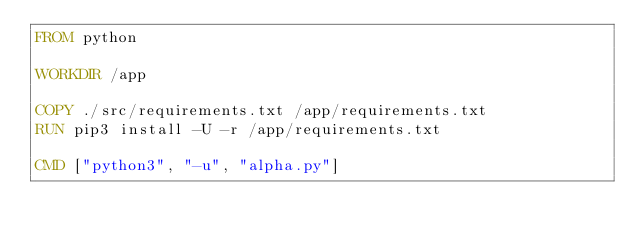Convert code to text. <code><loc_0><loc_0><loc_500><loc_500><_Dockerfile_>FROM python

WORKDIR /app

COPY ./src/requirements.txt /app/requirements.txt
RUN pip3 install -U -r /app/requirements.txt

CMD ["python3", "-u", "alpha.py"]
</code> 